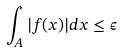<formula> <loc_0><loc_0><loc_500><loc_500>\int _ { A } | f ( x ) | d x \leq \epsilon</formula> 